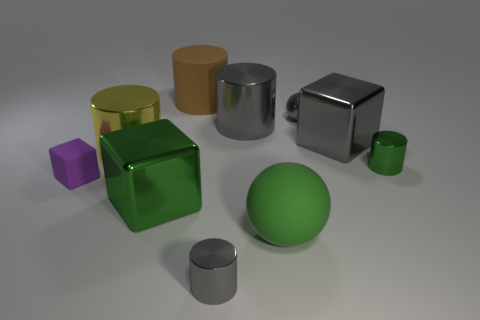Subtract all green metal cylinders. How many cylinders are left? 4 Subtract all brown cylinders. How many cylinders are left? 4 Subtract 1 cylinders. How many cylinders are left? 4 Subtract all red cylinders. Subtract all yellow cubes. How many cylinders are left? 5 Subtract all spheres. How many objects are left? 8 Add 8 gray cylinders. How many gray cylinders are left? 10 Add 7 brown things. How many brown things exist? 8 Subtract 0 red blocks. How many objects are left? 10 Subtract all yellow metallic cylinders. Subtract all brown shiny cubes. How many objects are left? 9 